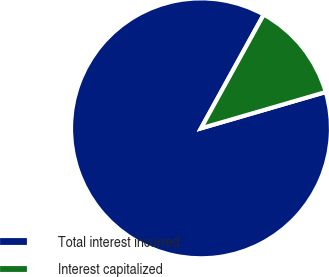Convert chart to OTSL. <chart><loc_0><loc_0><loc_500><loc_500><pie_chart><fcel>Total interest incurred<fcel>Interest capitalized<nl><fcel>87.53%<fcel>12.47%<nl></chart> 